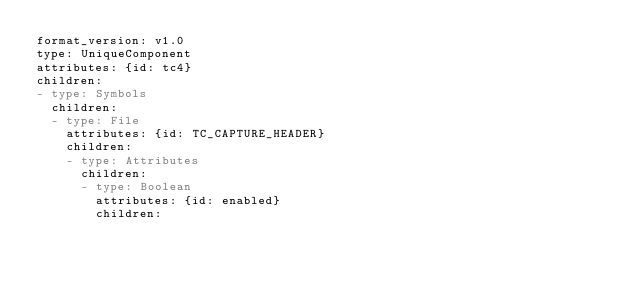Convert code to text. <code><loc_0><loc_0><loc_500><loc_500><_YAML_>format_version: v1.0
type: UniqueComponent
attributes: {id: tc4}
children:
- type: Symbols
  children:
  - type: File
    attributes: {id: TC_CAPTURE_HEADER}
    children:
    - type: Attributes
      children:
      - type: Boolean
        attributes: {id: enabled}
        children:</code> 